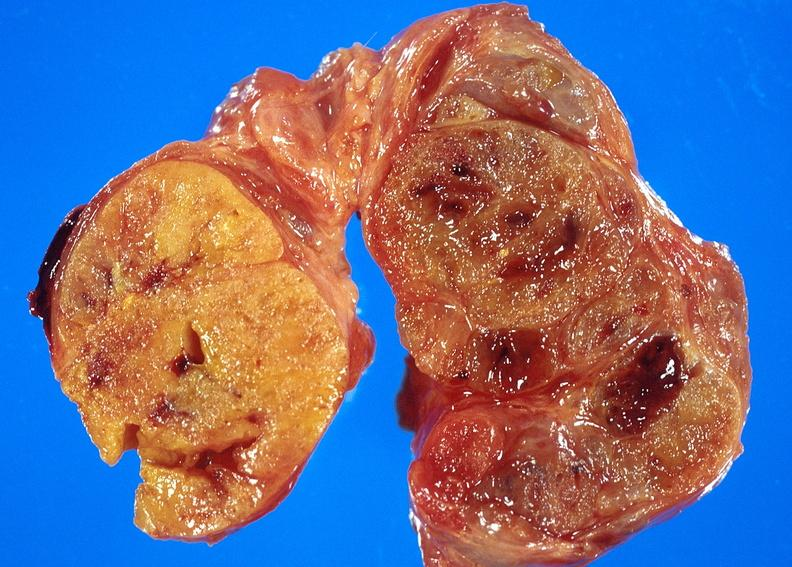where does this belong to?
Answer the question using a single word or phrase. Endocrine system 